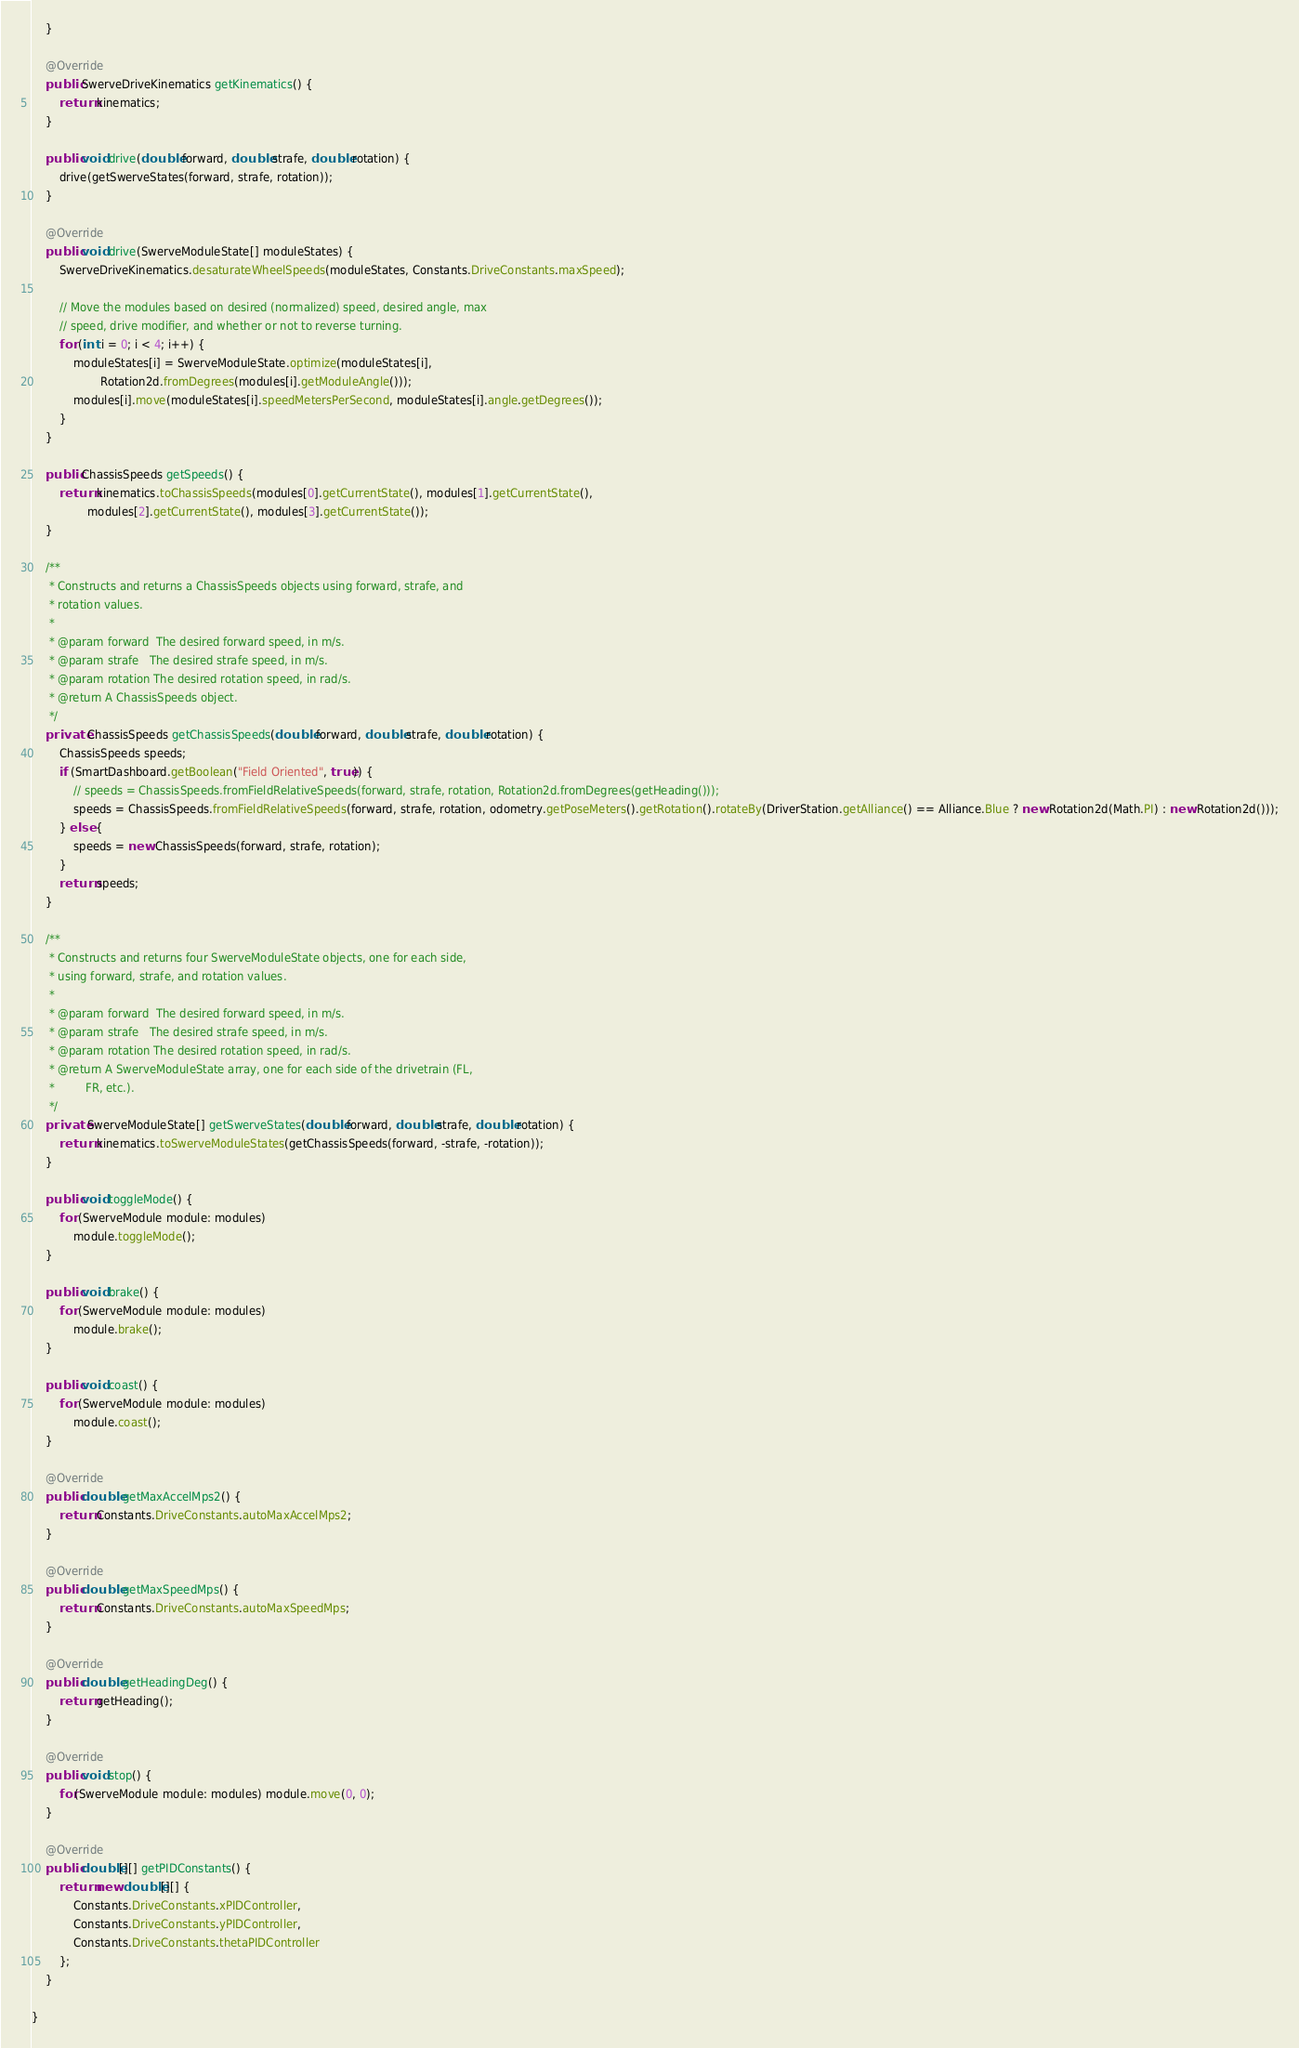<code> <loc_0><loc_0><loc_500><loc_500><_Java_>    }

    @Override
    public SwerveDriveKinematics getKinematics() {
        return kinematics;
    }

    public void drive(double forward, double strafe, double rotation) {
        drive(getSwerveStates(forward, strafe, rotation));
    }

    @Override
    public void drive(SwerveModuleState[] moduleStates) {
        SwerveDriveKinematics.desaturateWheelSpeeds(moduleStates, Constants.DriveConstants.maxSpeed);

        // Move the modules based on desired (normalized) speed, desired angle, max
        // speed, drive modifier, and whether or not to reverse turning.
        for (int i = 0; i < 4; i++) {
            moduleStates[i] = SwerveModuleState.optimize(moduleStates[i],
                    Rotation2d.fromDegrees(modules[i].getModuleAngle()));
            modules[i].move(moduleStates[i].speedMetersPerSecond, moduleStates[i].angle.getDegrees());
        }
    }

    public ChassisSpeeds getSpeeds() {
        return kinematics.toChassisSpeeds(modules[0].getCurrentState(), modules[1].getCurrentState(),
                modules[2].getCurrentState(), modules[3].getCurrentState());
    }

    /**
     * Constructs and returns a ChassisSpeeds objects using forward, strafe, and
     * rotation values.
     * 
     * @param forward  The desired forward speed, in m/s.
     * @param strafe   The desired strafe speed, in m/s.
     * @param rotation The desired rotation speed, in rad/s.
     * @return A ChassisSpeeds object.
     */
    private ChassisSpeeds getChassisSpeeds(double forward, double strafe, double rotation) {
        ChassisSpeeds speeds;
        if (SmartDashboard.getBoolean("Field Oriented", true)) {
            // speeds = ChassisSpeeds.fromFieldRelativeSpeeds(forward, strafe, rotation, Rotation2d.fromDegrees(getHeading()));
            speeds = ChassisSpeeds.fromFieldRelativeSpeeds(forward, strafe, rotation, odometry.getPoseMeters().getRotation().rotateBy(DriverStation.getAlliance() == Alliance.Blue ? new Rotation2d(Math.PI) : new Rotation2d()));
        } else {
            speeds = new ChassisSpeeds(forward, strafe, rotation);
        }
        return speeds;
    }

    /**
     * Constructs and returns four SwerveModuleState objects, one for each side,
     * using forward, strafe, and rotation values.
     * 
     * @param forward  The desired forward speed, in m/s.
     * @param strafe   The desired strafe speed, in m/s.
     * @param rotation The desired rotation speed, in rad/s.
     * @return A SwerveModuleState array, one for each side of the drivetrain (FL,
     *         FR, etc.).
     */
    private SwerveModuleState[] getSwerveStates(double forward, double strafe, double rotation) {
        return kinematics.toSwerveModuleStates(getChassisSpeeds(forward, -strafe, -rotation));
    }

    public void toggleMode() {
        for (SwerveModule module: modules)
            module.toggleMode();
    }

    public void brake() {
        for (SwerveModule module: modules)
            module.brake();
    }

    public void coast() {
        for (SwerveModule module: modules)
            module.coast();
    }

    @Override
    public double getMaxAccelMps2() {
        return Constants.DriveConstants.autoMaxAccelMps2;
    }

    @Override
    public double getMaxSpeedMps() {
        return Constants.DriveConstants.autoMaxSpeedMps;
    }

    @Override
    public double getHeadingDeg() {
        return getHeading();
    }

    @Override
    public void stop() {
        for(SwerveModule module: modules) module.move(0, 0);
    }

    @Override
    public double[][] getPIDConstants() {
        return new double[][] {
            Constants.DriveConstants.xPIDController,
            Constants.DriveConstants.yPIDController,
            Constants.DriveConstants.thetaPIDController
        };
    }

}
</code> 